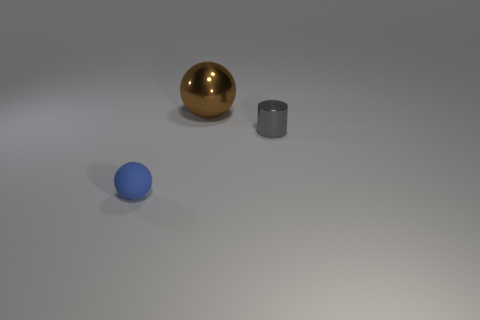There is a tiny gray shiny object; what shape is it? cylinder 